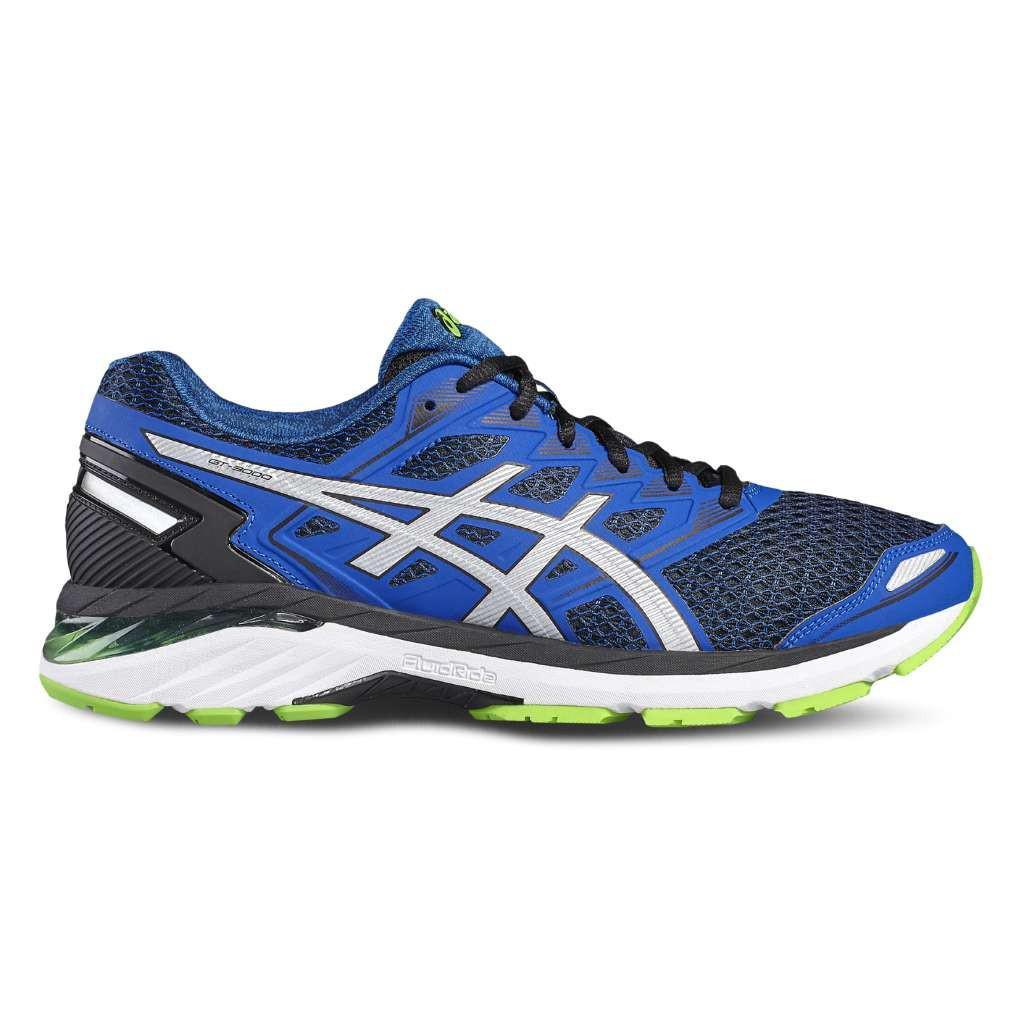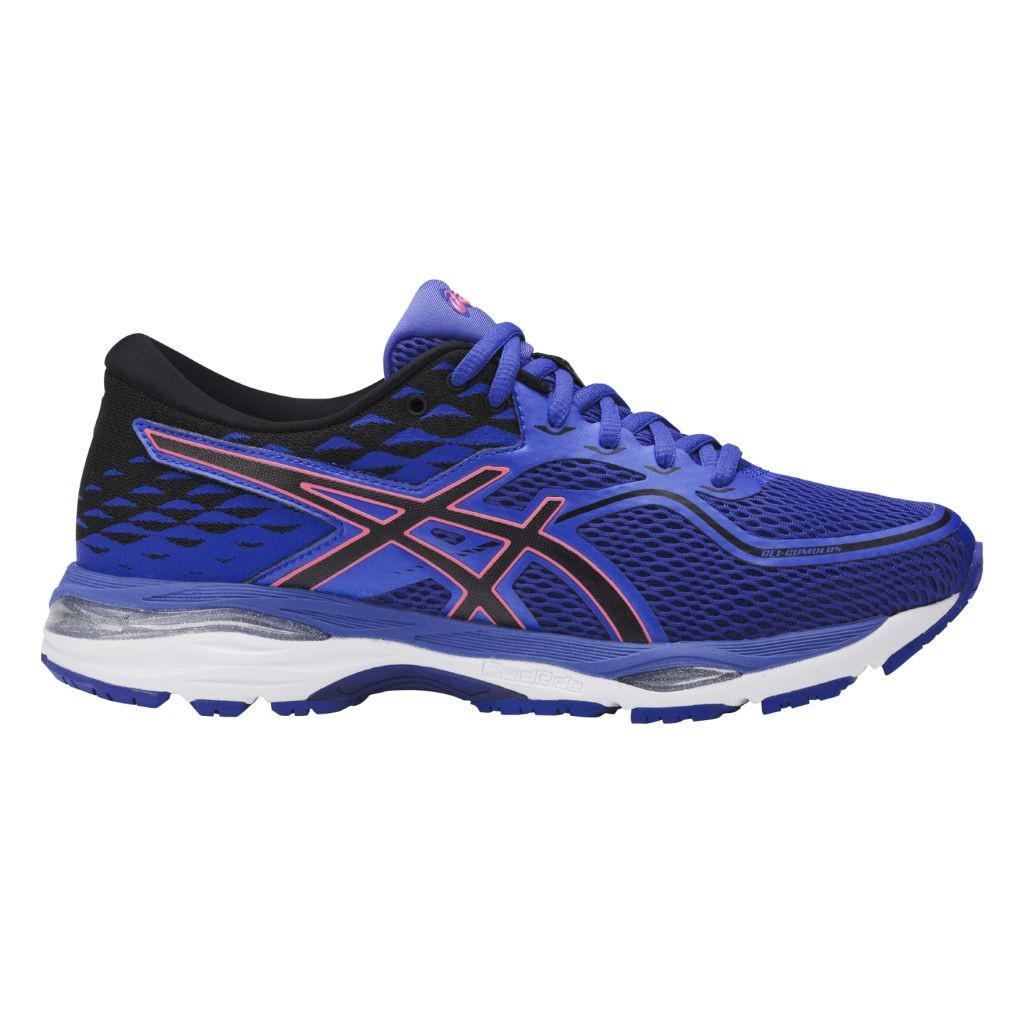The first image is the image on the left, the second image is the image on the right. For the images displayed, is the sentence "Each image shows one shoe with blue in its color scheme, and all shoes face rightward." factually correct? Answer yes or no. Yes. The first image is the image on the left, the second image is the image on the right. Given the left and right images, does the statement "Both shoes have the same logo across the side." hold true? Answer yes or no. Yes. 